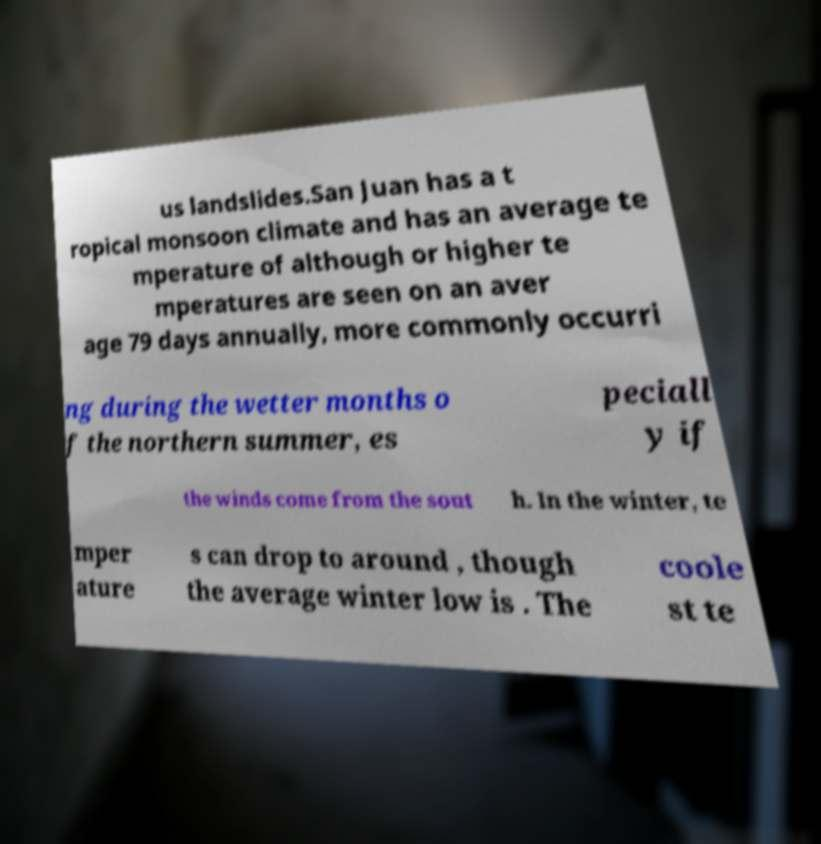Can you accurately transcribe the text from the provided image for me? us landslides.San Juan has a t ropical monsoon climate and has an average te mperature of although or higher te mperatures are seen on an aver age 79 days annually, more commonly occurri ng during the wetter months o f the northern summer, es peciall y if the winds come from the sout h. In the winter, te mper ature s can drop to around , though the average winter low is . The coole st te 